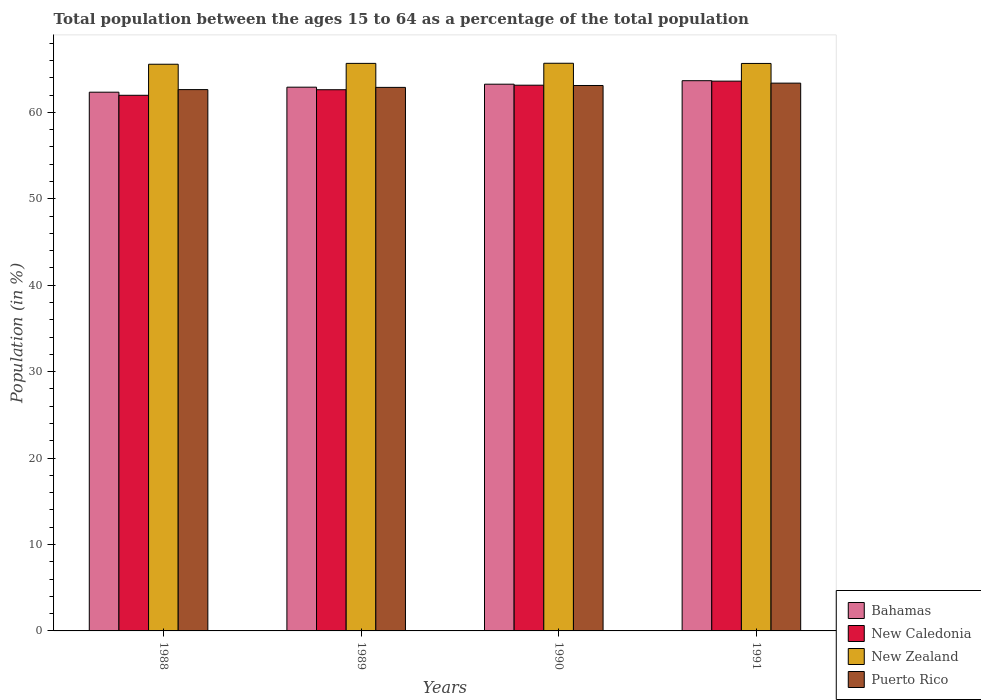How many different coloured bars are there?
Make the answer very short. 4. How many groups of bars are there?
Keep it short and to the point. 4. Are the number of bars on each tick of the X-axis equal?
Your answer should be compact. Yes. How many bars are there on the 2nd tick from the right?
Keep it short and to the point. 4. In how many cases, is the number of bars for a given year not equal to the number of legend labels?
Provide a succinct answer. 0. What is the percentage of the population ages 15 to 64 in Puerto Rico in 1990?
Offer a terse response. 63.1. Across all years, what is the maximum percentage of the population ages 15 to 64 in New Zealand?
Give a very brief answer. 65.67. Across all years, what is the minimum percentage of the population ages 15 to 64 in New Caledonia?
Make the answer very short. 61.97. In which year was the percentage of the population ages 15 to 64 in New Caledonia maximum?
Provide a short and direct response. 1991. In which year was the percentage of the population ages 15 to 64 in Bahamas minimum?
Offer a very short reply. 1988. What is the total percentage of the population ages 15 to 64 in Bahamas in the graph?
Make the answer very short. 252.13. What is the difference between the percentage of the population ages 15 to 64 in Puerto Rico in 1990 and that in 1991?
Ensure brevity in your answer.  -0.27. What is the difference between the percentage of the population ages 15 to 64 in Bahamas in 1989 and the percentage of the population ages 15 to 64 in Puerto Rico in 1990?
Offer a very short reply. -0.2. What is the average percentage of the population ages 15 to 64 in New Zealand per year?
Offer a terse response. 65.64. In the year 1988, what is the difference between the percentage of the population ages 15 to 64 in New Zealand and percentage of the population ages 15 to 64 in Puerto Rico?
Make the answer very short. 2.93. In how many years, is the percentage of the population ages 15 to 64 in Puerto Rico greater than 48?
Offer a terse response. 4. What is the ratio of the percentage of the population ages 15 to 64 in New Zealand in 1989 to that in 1990?
Offer a very short reply. 1. What is the difference between the highest and the second highest percentage of the population ages 15 to 64 in New Zealand?
Offer a terse response. 0.01. What is the difference between the highest and the lowest percentage of the population ages 15 to 64 in Bahamas?
Offer a terse response. 1.33. In how many years, is the percentage of the population ages 15 to 64 in New Caledonia greater than the average percentage of the population ages 15 to 64 in New Caledonia taken over all years?
Offer a very short reply. 2. Is the sum of the percentage of the population ages 15 to 64 in New Zealand in 1988 and 1989 greater than the maximum percentage of the population ages 15 to 64 in Puerto Rico across all years?
Your answer should be very brief. Yes. Is it the case that in every year, the sum of the percentage of the population ages 15 to 64 in New Zealand and percentage of the population ages 15 to 64 in Bahamas is greater than the sum of percentage of the population ages 15 to 64 in Puerto Rico and percentage of the population ages 15 to 64 in New Caledonia?
Your response must be concise. Yes. What does the 2nd bar from the left in 1991 represents?
Keep it short and to the point. New Caledonia. What does the 2nd bar from the right in 1990 represents?
Provide a short and direct response. New Zealand. What is the difference between two consecutive major ticks on the Y-axis?
Provide a short and direct response. 10. Are the values on the major ticks of Y-axis written in scientific E-notation?
Keep it short and to the point. No. Where does the legend appear in the graph?
Offer a terse response. Bottom right. How are the legend labels stacked?
Your answer should be very brief. Vertical. What is the title of the graph?
Your answer should be very brief. Total population between the ages 15 to 64 as a percentage of the total population. What is the label or title of the X-axis?
Provide a succinct answer. Years. What is the Population (in %) in Bahamas in 1988?
Your answer should be very brief. 62.32. What is the Population (in %) of New Caledonia in 1988?
Make the answer very short. 61.97. What is the Population (in %) of New Zealand in 1988?
Your answer should be compact. 65.56. What is the Population (in %) in Puerto Rico in 1988?
Offer a terse response. 62.62. What is the Population (in %) in Bahamas in 1989?
Your response must be concise. 62.9. What is the Population (in %) in New Caledonia in 1989?
Provide a succinct answer. 62.61. What is the Population (in %) of New Zealand in 1989?
Offer a very short reply. 65.66. What is the Population (in %) of Puerto Rico in 1989?
Offer a very short reply. 62.88. What is the Population (in %) in Bahamas in 1990?
Your answer should be compact. 63.25. What is the Population (in %) of New Caledonia in 1990?
Provide a succinct answer. 63.14. What is the Population (in %) of New Zealand in 1990?
Keep it short and to the point. 65.67. What is the Population (in %) of Puerto Rico in 1990?
Ensure brevity in your answer.  63.1. What is the Population (in %) in Bahamas in 1991?
Ensure brevity in your answer.  63.65. What is the Population (in %) of New Caledonia in 1991?
Keep it short and to the point. 63.6. What is the Population (in %) in New Zealand in 1991?
Offer a very short reply. 65.65. What is the Population (in %) of Puerto Rico in 1991?
Give a very brief answer. 63.37. Across all years, what is the maximum Population (in %) of Bahamas?
Make the answer very short. 63.65. Across all years, what is the maximum Population (in %) of New Caledonia?
Your response must be concise. 63.6. Across all years, what is the maximum Population (in %) in New Zealand?
Provide a succinct answer. 65.67. Across all years, what is the maximum Population (in %) of Puerto Rico?
Your answer should be very brief. 63.37. Across all years, what is the minimum Population (in %) in Bahamas?
Provide a succinct answer. 62.32. Across all years, what is the minimum Population (in %) in New Caledonia?
Provide a short and direct response. 61.97. Across all years, what is the minimum Population (in %) of New Zealand?
Make the answer very short. 65.56. Across all years, what is the minimum Population (in %) in Puerto Rico?
Your answer should be compact. 62.62. What is the total Population (in %) of Bahamas in the graph?
Your answer should be compact. 252.13. What is the total Population (in %) of New Caledonia in the graph?
Keep it short and to the point. 251.32. What is the total Population (in %) of New Zealand in the graph?
Ensure brevity in your answer.  262.54. What is the total Population (in %) in Puerto Rico in the graph?
Offer a terse response. 251.98. What is the difference between the Population (in %) of Bahamas in 1988 and that in 1989?
Your answer should be compact. -0.58. What is the difference between the Population (in %) of New Caledonia in 1988 and that in 1989?
Your response must be concise. -0.64. What is the difference between the Population (in %) in New Zealand in 1988 and that in 1989?
Offer a terse response. -0.1. What is the difference between the Population (in %) in Puerto Rico in 1988 and that in 1989?
Your answer should be very brief. -0.26. What is the difference between the Population (in %) of Bahamas in 1988 and that in 1990?
Provide a succinct answer. -0.93. What is the difference between the Population (in %) in New Caledonia in 1988 and that in 1990?
Offer a terse response. -1.17. What is the difference between the Population (in %) of New Zealand in 1988 and that in 1990?
Make the answer very short. -0.11. What is the difference between the Population (in %) in Puerto Rico in 1988 and that in 1990?
Keep it short and to the point. -0.48. What is the difference between the Population (in %) in Bahamas in 1988 and that in 1991?
Provide a succinct answer. -1.33. What is the difference between the Population (in %) of New Caledonia in 1988 and that in 1991?
Your answer should be very brief. -1.64. What is the difference between the Population (in %) in New Zealand in 1988 and that in 1991?
Offer a very short reply. -0.09. What is the difference between the Population (in %) in Puerto Rico in 1988 and that in 1991?
Your answer should be very brief. -0.75. What is the difference between the Population (in %) of Bahamas in 1989 and that in 1990?
Give a very brief answer. -0.34. What is the difference between the Population (in %) in New Caledonia in 1989 and that in 1990?
Ensure brevity in your answer.  -0.52. What is the difference between the Population (in %) of New Zealand in 1989 and that in 1990?
Keep it short and to the point. -0.01. What is the difference between the Population (in %) of Puerto Rico in 1989 and that in 1990?
Provide a succinct answer. -0.22. What is the difference between the Population (in %) of Bahamas in 1989 and that in 1991?
Provide a short and direct response. -0.75. What is the difference between the Population (in %) of New Caledonia in 1989 and that in 1991?
Offer a very short reply. -0.99. What is the difference between the Population (in %) in New Zealand in 1989 and that in 1991?
Your answer should be very brief. 0.01. What is the difference between the Population (in %) of Puerto Rico in 1989 and that in 1991?
Keep it short and to the point. -0.49. What is the difference between the Population (in %) of Bahamas in 1990 and that in 1991?
Provide a succinct answer. -0.4. What is the difference between the Population (in %) in New Caledonia in 1990 and that in 1991?
Ensure brevity in your answer.  -0.47. What is the difference between the Population (in %) in New Zealand in 1990 and that in 1991?
Offer a terse response. 0.02. What is the difference between the Population (in %) in Puerto Rico in 1990 and that in 1991?
Provide a short and direct response. -0.27. What is the difference between the Population (in %) in Bahamas in 1988 and the Population (in %) in New Caledonia in 1989?
Give a very brief answer. -0.29. What is the difference between the Population (in %) in Bahamas in 1988 and the Population (in %) in New Zealand in 1989?
Your response must be concise. -3.33. What is the difference between the Population (in %) of Bahamas in 1988 and the Population (in %) of Puerto Rico in 1989?
Offer a very short reply. -0.56. What is the difference between the Population (in %) of New Caledonia in 1988 and the Population (in %) of New Zealand in 1989?
Ensure brevity in your answer.  -3.69. What is the difference between the Population (in %) of New Caledonia in 1988 and the Population (in %) of Puerto Rico in 1989?
Offer a very short reply. -0.92. What is the difference between the Population (in %) of New Zealand in 1988 and the Population (in %) of Puerto Rico in 1989?
Offer a terse response. 2.68. What is the difference between the Population (in %) of Bahamas in 1988 and the Population (in %) of New Caledonia in 1990?
Offer a very short reply. -0.81. What is the difference between the Population (in %) of Bahamas in 1988 and the Population (in %) of New Zealand in 1990?
Make the answer very short. -3.35. What is the difference between the Population (in %) in Bahamas in 1988 and the Population (in %) in Puerto Rico in 1990?
Keep it short and to the point. -0.78. What is the difference between the Population (in %) of New Caledonia in 1988 and the Population (in %) of New Zealand in 1990?
Offer a very short reply. -3.71. What is the difference between the Population (in %) of New Caledonia in 1988 and the Population (in %) of Puerto Rico in 1990?
Your response must be concise. -1.13. What is the difference between the Population (in %) in New Zealand in 1988 and the Population (in %) in Puerto Rico in 1990?
Your answer should be very brief. 2.46. What is the difference between the Population (in %) in Bahamas in 1988 and the Population (in %) in New Caledonia in 1991?
Make the answer very short. -1.28. What is the difference between the Population (in %) in Bahamas in 1988 and the Population (in %) in New Zealand in 1991?
Provide a short and direct response. -3.33. What is the difference between the Population (in %) in Bahamas in 1988 and the Population (in %) in Puerto Rico in 1991?
Your answer should be very brief. -1.05. What is the difference between the Population (in %) in New Caledonia in 1988 and the Population (in %) in New Zealand in 1991?
Offer a terse response. -3.68. What is the difference between the Population (in %) in New Caledonia in 1988 and the Population (in %) in Puerto Rico in 1991?
Give a very brief answer. -1.41. What is the difference between the Population (in %) of New Zealand in 1988 and the Population (in %) of Puerto Rico in 1991?
Provide a short and direct response. 2.19. What is the difference between the Population (in %) of Bahamas in 1989 and the Population (in %) of New Caledonia in 1990?
Keep it short and to the point. -0.23. What is the difference between the Population (in %) in Bahamas in 1989 and the Population (in %) in New Zealand in 1990?
Your response must be concise. -2.77. What is the difference between the Population (in %) in Bahamas in 1989 and the Population (in %) in Puerto Rico in 1990?
Provide a succinct answer. -0.2. What is the difference between the Population (in %) of New Caledonia in 1989 and the Population (in %) of New Zealand in 1990?
Your response must be concise. -3.06. What is the difference between the Population (in %) of New Caledonia in 1989 and the Population (in %) of Puerto Rico in 1990?
Your response must be concise. -0.49. What is the difference between the Population (in %) in New Zealand in 1989 and the Population (in %) in Puerto Rico in 1990?
Ensure brevity in your answer.  2.56. What is the difference between the Population (in %) of Bahamas in 1989 and the Population (in %) of New Caledonia in 1991?
Provide a short and direct response. -0.7. What is the difference between the Population (in %) in Bahamas in 1989 and the Population (in %) in New Zealand in 1991?
Make the answer very short. -2.75. What is the difference between the Population (in %) of Bahamas in 1989 and the Population (in %) of Puerto Rico in 1991?
Offer a terse response. -0.47. What is the difference between the Population (in %) of New Caledonia in 1989 and the Population (in %) of New Zealand in 1991?
Provide a short and direct response. -3.04. What is the difference between the Population (in %) of New Caledonia in 1989 and the Population (in %) of Puerto Rico in 1991?
Ensure brevity in your answer.  -0.76. What is the difference between the Population (in %) of New Zealand in 1989 and the Population (in %) of Puerto Rico in 1991?
Your response must be concise. 2.29. What is the difference between the Population (in %) in Bahamas in 1990 and the Population (in %) in New Caledonia in 1991?
Make the answer very short. -0.35. What is the difference between the Population (in %) of Bahamas in 1990 and the Population (in %) of New Zealand in 1991?
Your response must be concise. -2.4. What is the difference between the Population (in %) of Bahamas in 1990 and the Population (in %) of Puerto Rico in 1991?
Provide a succinct answer. -0.12. What is the difference between the Population (in %) in New Caledonia in 1990 and the Population (in %) in New Zealand in 1991?
Your response must be concise. -2.52. What is the difference between the Population (in %) of New Caledonia in 1990 and the Population (in %) of Puerto Rico in 1991?
Make the answer very short. -0.24. What is the difference between the Population (in %) in New Zealand in 1990 and the Population (in %) in Puerto Rico in 1991?
Your answer should be compact. 2.3. What is the average Population (in %) of Bahamas per year?
Offer a very short reply. 63.03. What is the average Population (in %) in New Caledonia per year?
Offer a terse response. 62.83. What is the average Population (in %) in New Zealand per year?
Your response must be concise. 65.64. What is the average Population (in %) in Puerto Rico per year?
Make the answer very short. 62.99. In the year 1988, what is the difference between the Population (in %) of Bahamas and Population (in %) of New Caledonia?
Offer a very short reply. 0.36. In the year 1988, what is the difference between the Population (in %) of Bahamas and Population (in %) of New Zealand?
Your answer should be very brief. -3.24. In the year 1988, what is the difference between the Population (in %) in Bahamas and Population (in %) in Puerto Rico?
Keep it short and to the point. -0.3. In the year 1988, what is the difference between the Population (in %) of New Caledonia and Population (in %) of New Zealand?
Offer a terse response. -3.59. In the year 1988, what is the difference between the Population (in %) of New Caledonia and Population (in %) of Puerto Rico?
Your answer should be compact. -0.66. In the year 1988, what is the difference between the Population (in %) in New Zealand and Population (in %) in Puerto Rico?
Keep it short and to the point. 2.93. In the year 1989, what is the difference between the Population (in %) of Bahamas and Population (in %) of New Caledonia?
Your answer should be compact. 0.29. In the year 1989, what is the difference between the Population (in %) in Bahamas and Population (in %) in New Zealand?
Your answer should be very brief. -2.75. In the year 1989, what is the difference between the Population (in %) in Bahamas and Population (in %) in Puerto Rico?
Offer a very short reply. 0.02. In the year 1989, what is the difference between the Population (in %) in New Caledonia and Population (in %) in New Zealand?
Your answer should be compact. -3.05. In the year 1989, what is the difference between the Population (in %) in New Caledonia and Population (in %) in Puerto Rico?
Ensure brevity in your answer.  -0.27. In the year 1989, what is the difference between the Population (in %) of New Zealand and Population (in %) of Puerto Rico?
Provide a short and direct response. 2.78. In the year 1990, what is the difference between the Population (in %) of Bahamas and Population (in %) of New Caledonia?
Give a very brief answer. 0.11. In the year 1990, what is the difference between the Population (in %) in Bahamas and Population (in %) in New Zealand?
Your answer should be compact. -2.42. In the year 1990, what is the difference between the Population (in %) in Bahamas and Population (in %) in Puerto Rico?
Your response must be concise. 0.15. In the year 1990, what is the difference between the Population (in %) in New Caledonia and Population (in %) in New Zealand?
Keep it short and to the point. -2.54. In the year 1990, what is the difference between the Population (in %) of New Caledonia and Population (in %) of Puerto Rico?
Keep it short and to the point. 0.04. In the year 1990, what is the difference between the Population (in %) of New Zealand and Population (in %) of Puerto Rico?
Keep it short and to the point. 2.57. In the year 1991, what is the difference between the Population (in %) of Bahamas and Population (in %) of New Caledonia?
Provide a short and direct response. 0.05. In the year 1991, what is the difference between the Population (in %) in Bahamas and Population (in %) in New Zealand?
Your response must be concise. -2. In the year 1991, what is the difference between the Population (in %) of Bahamas and Population (in %) of Puerto Rico?
Ensure brevity in your answer.  0.28. In the year 1991, what is the difference between the Population (in %) of New Caledonia and Population (in %) of New Zealand?
Keep it short and to the point. -2.05. In the year 1991, what is the difference between the Population (in %) of New Caledonia and Population (in %) of Puerto Rico?
Ensure brevity in your answer.  0.23. In the year 1991, what is the difference between the Population (in %) of New Zealand and Population (in %) of Puerto Rico?
Your answer should be very brief. 2.28. What is the ratio of the Population (in %) of Bahamas in 1988 to that in 1989?
Your response must be concise. 0.99. What is the ratio of the Population (in %) of New Caledonia in 1988 to that in 1989?
Offer a terse response. 0.99. What is the ratio of the Population (in %) in New Zealand in 1988 to that in 1989?
Ensure brevity in your answer.  1. What is the ratio of the Population (in %) in Bahamas in 1988 to that in 1990?
Ensure brevity in your answer.  0.99. What is the ratio of the Population (in %) of New Caledonia in 1988 to that in 1990?
Provide a succinct answer. 0.98. What is the ratio of the Population (in %) in Bahamas in 1988 to that in 1991?
Ensure brevity in your answer.  0.98. What is the ratio of the Population (in %) in New Caledonia in 1988 to that in 1991?
Your answer should be very brief. 0.97. What is the ratio of the Population (in %) in New Zealand in 1988 to that in 1991?
Provide a short and direct response. 1. What is the ratio of the Population (in %) of Puerto Rico in 1988 to that in 1991?
Provide a succinct answer. 0.99. What is the ratio of the Population (in %) in Bahamas in 1989 to that in 1990?
Make the answer very short. 0.99. What is the ratio of the Population (in %) of New Caledonia in 1989 to that in 1990?
Your answer should be compact. 0.99. What is the ratio of the Population (in %) in Puerto Rico in 1989 to that in 1990?
Make the answer very short. 1. What is the ratio of the Population (in %) in New Caledonia in 1989 to that in 1991?
Provide a succinct answer. 0.98. What is the ratio of the Population (in %) in New Zealand in 1989 to that in 1991?
Make the answer very short. 1. What is the ratio of the Population (in %) of Bahamas in 1990 to that in 1991?
Offer a very short reply. 0.99. What is the ratio of the Population (in %) in New Caledonia in 1990 to that in 1991?
Your response must be concise. 0.99. What is the ratio of the Population (in %) in New Zealand in 1990 to that in 1991?
Keep it short and to the point. 1. What is the ratio of the Population (in %) in Puerto Rico in 1990 to that in 1991?
Your response must be concise. 1. What is the difference between the highest and the second highest Population (in %) in Bahamas?
Your response must be concise. 0.4. What is the difference between the highest and the second highest Population (in %) in New Caledonia?
Your answer should be compact. 0.47. What is the difference between the highest and the second highest Population (in %) in New Zealand?
Provide a short and direct response. 0.01. What is the difference between the highest and the second highest Population (in %) of Puerto Rico?
Offer a very short reply. 0.27. What is the difference between the highest and the lowest Population (in %) of Bahamas?
Provide a succinct answer. 1.33. What is the difference between the highest and the lowest Population (in %) in New Caledonia?
Offer a terse response. 1.64. What is the difference between the highest and the lowest Population (in %) in New Zealand?
Make the answer very short. 0.11. What is the difference between the highest and the lowest Population (in %) in Puerto Rico?
Give a very brief answer. 0.75. 